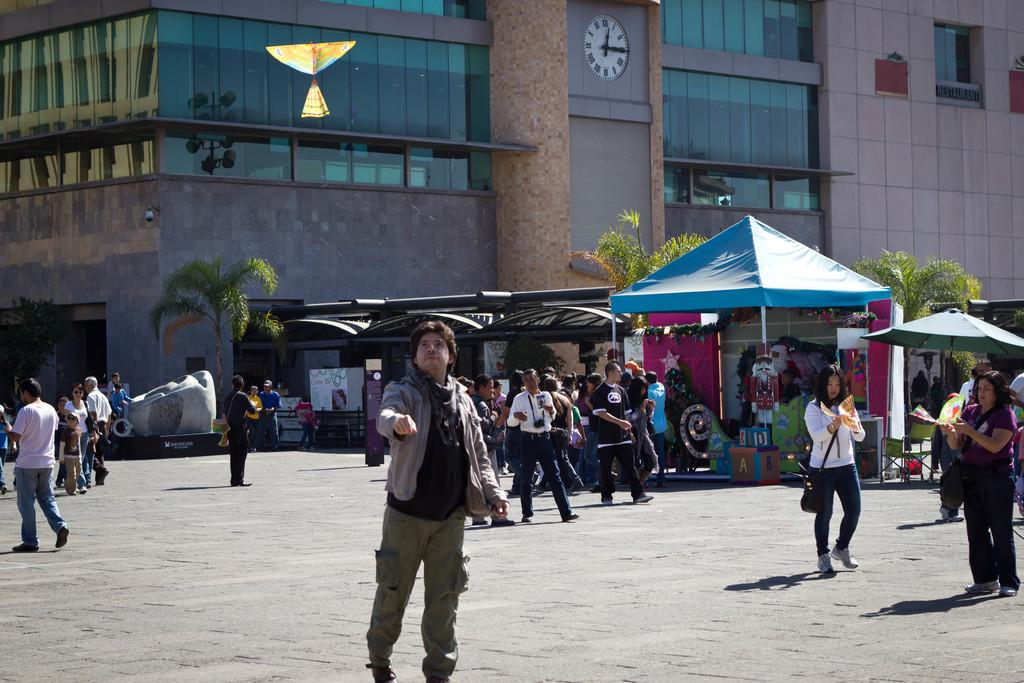Who or what can be seen in the image? There are people in the image. What can be seen in the distance behind the people? There are trees and a building in the background of the image. What type of cracker is being used to make a connection in the image? There is no cracker or act of making a connection present in the image. 